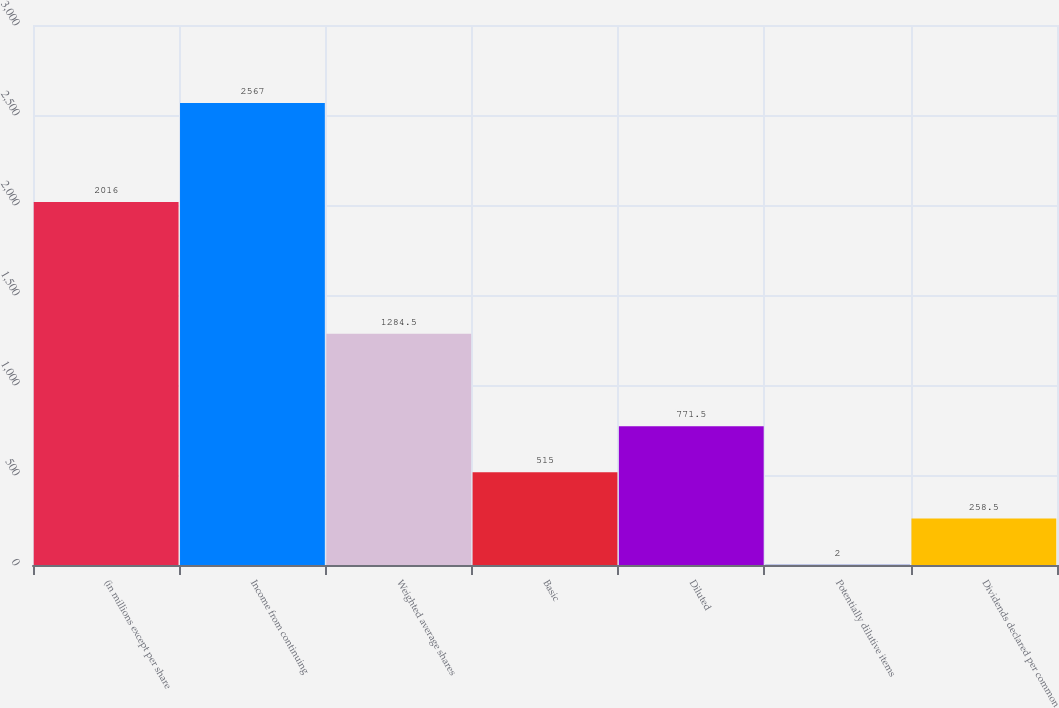Convert chart. <chart><loc_0><loc_0><loc_500><loc_500><bar_chart><fcel>(in millions except per share<fcel>Income from continuing<fcel>Weighted average shares<fcel>Basic<fcel>Diluted<fcel>Potentially dilutive items<fcel>Dividends declared per common<nl><fcel>2016<fcel>2567<fcel>1284.5<fcel>515<fcel>771.5<fcel>2<fcel>258.5<nl></chart> 